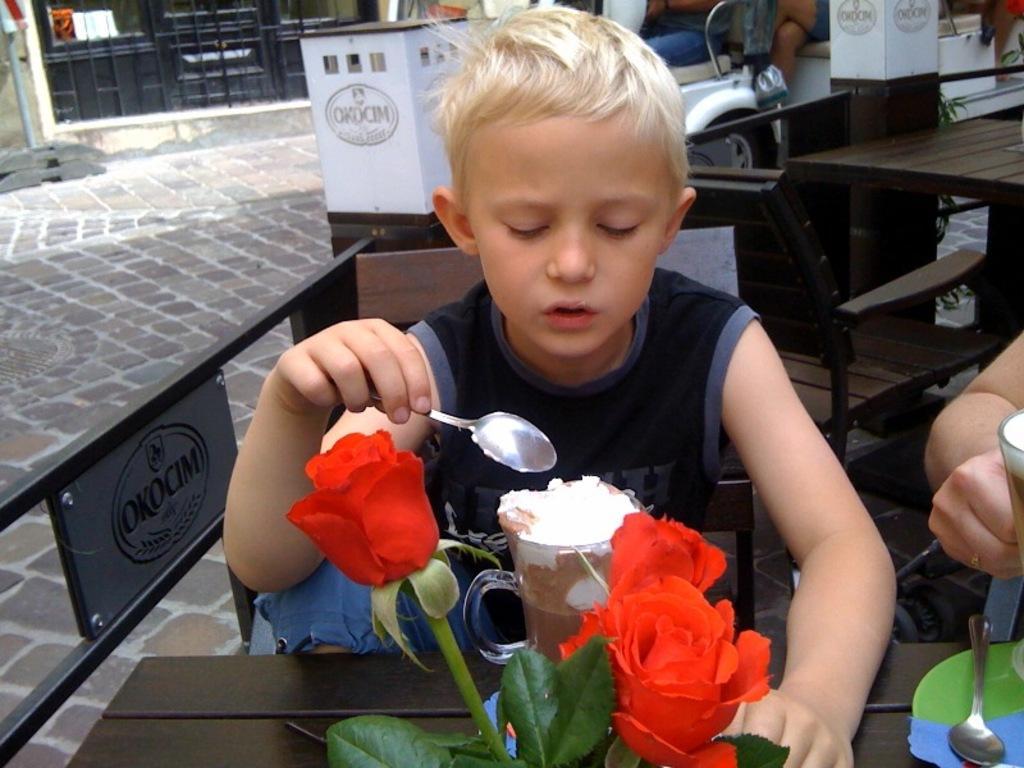In one or two sentences, can you explain what this image depicts? In the foreground of this picture we can see a wooden table on the top of which red roses, green leaves, some food items and some other items and places and we can see a kid wearing black color t-shirt, holding a spoon and sitting on the chair. On the right corner we can see the hand of a person. In the background we can see the table, chairs, vehicle, door of the building, metal rods and some other objects and the pavement. 